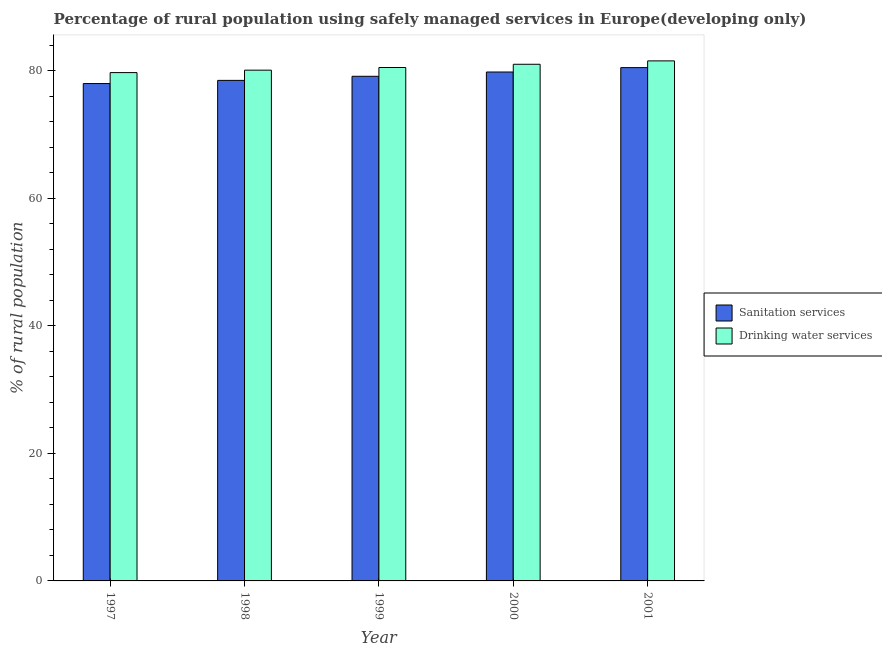How many groups of bars are there?
Your answer should be compact. 5. Are the number of bars per tick equal to the number of legend labels?
Make the answer very short. Yes. How many bars are there on the 3rd tick from the left?
Ensure brevity in your answer.  2. How many bars are there on the 5th tick from the right?
Provide a short and direct response. 2. In how many cases, is the number of bars for a given year not equal to the number of legend labels?
Offer a terse response. 0. What is the percentage of rural population who used sanitation services in 1999?
Your response must be concise. 79.12. Across all years, what is the maximum percentage of rural population who used sanitation services?
Your answer should be compact. 80.48. Across all years, what is the minimum percentage of rural population who used drinking water services?
Provide a short and direct response. 79.7. In which year was the percentage of rural population who used sanitation services minimum?
Your response must be concise. 1997. What is the total percentage of rural population who used drinking water services in the graph?
Provide a short and direct response. 402.84. What is the difference between the percentage of rural population who used sanitation services in 1999 and that in 2000?
Your answer should be compact. -0.67. What is the difference between the percentage of rural population who used sanitation services in 2001 and the percentage of rural population who used drinking water services in 1999?
Offer a very short reply. 1.36. What is the average percentage of rural population who used drinking water services per year?
Make the answer very short. 80.57. In the year 1999, what is the difference between the percentage of rural population who used drinking water services and percentage of rural population who used sanitation services?
Offer a very short reply. 0. In how many years, is the percentage of rural population who used sanitation services greater than 48 %?
Give a very brief answer. 5. What is the ratio of the percentage of rural population who used sanitation services in 2000 to that in 2001?
Provide a succinct answer. 0.99. Is the percentage of rural population who used sanitation services in 1998 less than that in 2000?
Keep it short and to the point. Yes. What is the difference between the highest and the second highest percentage of rural population who used drinking water services?
Provide a short and direct response. 0.53. What is the difference between the highest and the lowest percentage of rural population who used sanitation services?
Ensure brevity in your answer.  2.5. In how many years, is the percentage of rural population who used sanitation services greater than the average percentage of rural population who used sanitation services taken over all years?
Your answer should be compact. 2. Is the sum of the percentage of rural population who used drinking water services in 1997 and 1998 greater than the maximum percentage of rural population who used sanitation services across all years?
Offer a very short reply. Yes. What does the 1st bar from the left in 2000 represents?
Make the answer very short. Sanitation services. What does the 1st bar from the right in 1999 represents?
Your answer should be compact. Drinking water services. Are all the bars in the graph horizontal?
Provide a short and direct response. No. How many years are there in the graph?
Ensure brevity in your answer.  5. What is the difference between two consecutive major ticks on the Y-axis?
Make the answer very short. 20. Does the graph contain any zero values?
Provide a succinct answer. No. Does the graph contain grids?
Provide a short and direct response. No. Where does the legend appear in the graph?
Provide a short and direct response. Center right. What is the title of the graph?
Your answer should be compact. Percentage of rural population using safely managed services in Europe(developing only). What is the label or title of the Y-axis?
Ensure brevity in your answer.  % of rural population. What is the % of rural population in Sanitation services in 1997?
Ensure brevity in your answer.  77.99. What is the % of rural population of Drinking water services in 1997?
Your answer should be compact. 79.7. What is the % of rural population in Sanitation services in 1998?
Make the answer very short. 78.48. What is the % of rural population of Drinking water services in 1998?
Provide a succinct answer. 80.08. What is the % of rural population of Sanitation services in 1999?
Provide a succinct answer. 79.12. What is the % of rural population in Drinking water services in 1999?
Keep it short and to the point. 80.5. What is the % of rural population in Sanitation services in 2000?
Your answer should be very brief. 79.8. What is the % of rural population of Drinking water services in 2000?
Provide a succinct answer. 81.01. What is the % of rural population in Sanitation services in 2001?
Offer a terse response. 80.48. What is the % of rural population of Drinking water services in 2001?
Your response must be concise. 81.54. Across all years, what is the maximum % of rural population of Sanitation services?
Offer a terse response. 80.48. Across all years, what is the maximum % of rural population in Drinking water services?
Offer a very short reply. 81.54. Across all years, what is the minimum % of rural population in Sanitation services?
Offer a very short reply. 77.99. Across all years, what is the minimum % of rural population in Drinking water services?
Give a very brief answer. 79.7. What is the total % of rural population in Sanitation services in the graph?
Ensure brevity in your answer.  395.87. What is the total % of rural population of Drinking water services in the graph?
Give a very brief answer. 402.84. What is the difference between the % of rural population of Sanitation services in 1997 and that in 1998?
Provide a short and direct response. -0.5. What is the difference between the % of rural population of Drinking water services in 1997 and that in 1998?
Ensure brevity in your answer.  -0.38. What is the difference between the % of rural population in Sanitation services in 1997 and that in 1999?
Provide a succinct answer. -1.14. What is the difference between the % of rural population of Drinking water services in 1997 and that in 1999?
Provide a short and direct response. -0.8. What is the difference between the % of rural population in Sanitation services in 1997 and that in 2000?
Ensure brevity in your answer.  -1.81. What is the difference between the % of rural population in Drinking water services in 1997 and that in 2000?
Offer a very short reply. -1.31. What is the difference between the % of rural population of Sanitation services in 1997 and that in 2001?
Your response must be concise. -2.5. What is the difference between the % of rural population in Drinking water services in 1997 and that in 2001?
Ensure brevity in your answer.  -1.84. What is the difference between the % of rural population of Sanitation services in 1998 and that in 1999?
Provide a short and direct response. -0.64. What is the difference between the % of rural population of Drinking water services in 1998 and that in 1999?
Keep it short and to the point. -0.42. What is the difference between the % of rural population of Sanitation services in 1998 and that in 2000?
Your response must be concise. -1.31. What is the difference between the % of rural population of Drinking water services in 1998 and that in 2000?
Offer a terse response. -0.92. What is the difference between the % of rural population of Sanitation services in 1998 and that in 2001?
Your answer should be very brief. -2. What is the difference between the % of rural population of Drinking water services in 1998 and that in 2001?
Provide a succinct answer. -1.46. What is the difference between the % of rural population of Sanitation services in 1999 and that in 2000?
Ensure brevity in your answer.  -0.67. What is the difference between the % of rural population of Drinking water services in 1999 and that in 2000?
Your response must be concise. -0.51. What is the difference between the % of rural population of Sanitation services in 1999 and that in 2001?
Offer a terse response. -1.36. What is the difference between the % of rural population of Drinking water services in 1999 and that in 2001?
Offer a terse response. -1.04. What is the difference between the % of rural population of Sanitation services in 2000 and that in 2001?
Your response must be concise. -0.69. What is the difference between the % of rural population in Drinking water services in 2000 and that in 2001?
Provide a short and direct response. -0.53. What is the difference between the % of rural population in Sanitation services in 1997 and the % of rural population in Drinking water services in 1998?
Give a very brief answer. -2.1. What is the difference between the % of rural population in Sanitation services in 1997 and the % of rural population in Drinking water services in 1999?
Give a very brief answer. -2.52. What is the difference between the % of rural population in Sanitation services in 1997 and the % of rural population in Drinking water services in 2000?
Provide a short and direct response. -3.02. What is the difference between the % of rural population of Sanitation services in 1997 and the % of rural population of Drinking water services in 2001?
Provide a short and direct response. -3.56. What is the difference between the % of rural population in Sanitation services in 1998 and the % of rural population in Drinking water services in 1999?
Give a very brief answer. -2.02. What is the difference between the % of rural population of Sanitation services in 1998 and the % of rural population of Drinking water services in 2000?
Provide a succinct answer. -2.53. What is the difference between the % of rural population in Sanitation services in 1998 and the % of rural population in Drinking water services in 2001?
Provide a short and direct response. -3.06. What is the difference between the % of rural population of Sanitation services in 1999 and the % of rural population of Drinking water services in 2000?
Offer a very short reply. -1.88. What is the difference between the % of rural population of Sanitation services in 1999 and the % of rural population of Drinking water services in 2001?
Make the answer very short. -2.42. What is the difference between the % of rural population of Sanitation services in 2000 and the % of rural population of Drinking water services in 2001?
Your answer should be compact. -1.74. What is the average % of rural population of Sanitation services per year?
Make the answer very short. 79.17. What is the average % of rural population of Drinking water services per year?
Keep it short and to the point. 80.57. In the year 1997, what is the difference between the % of rural population of Sanitation services and % of rural population of Drinking water services?
Your answer should be very brief. -1.72. In the year 1998, what is the difference between the % of rural population in Sanitation services and % of rural population in Drinking water services?
Provide a succinct answer. -1.6. In the year 1999, what is the difference between the % of rural population of Sanitation services and % of rural population of Drinking water services?
Provide a succinct answer. -1.38. In the year 2000, what is the difference between the % of rural population in Sanitation services and % of rural population in Drinking water services?
Your answer should be compact. -1.21. In the year 2001, what is the difference between the % of rural population of Sanitation services and % of rural population of Drinking water services?
Provide a short and direct response. -1.06. What is the ratio of the % of rural population in Drinking water services in 1997 to that in 1998?
Keep it short and to the point. 1. What is the ratio of the % of rural population in Sanitation services in 1997 to that in 1999?
Provide a short and direct response. 0.99. What is the ratio of the % of rural population in Sanitation services in 1997 to that in 2000?
Make the answer very short. 0.98. What is the ratio of the % of rural population of Drinking water services in 1997 to that in 2000?
Your response must be concise. 0.98. What is the ratio of the % of rural population in Sanitation services in 1997 to that in 2001?
Give a very brief answer. 0.97. What is the ratio of the % of rural population of Drinking water services in 1997 to that in 2001?
Your answer should be compact. 0.98. What is the ratio of the % of rural population in Sanitation services in 1998 to that in 2000?
Your answer should be compact. 0.98. What is the ratio of the % of rural population in Drinking water services in 1998 to that in 2000?
Provide a short and direct response. 0.99. What is the ratio of the % of rural population in Sanitation services in 1998 to that in 2001?
Provide a short and direct response. 0.98. What is the ratio of the % of rural population of Drinking water services in 1998 to that in 2001?
Offer a very short reply. 0.98. What is the ratio of the % of rural population in Sanitation services in 1999 to that in 2000?
Your answer should be very brief. 0.99. What is the ratio of the % of rural population of Sanitation services in 1999 to that in 2001?
Your answer should be compact. 0.98. What is the ratio of the % of rural population in Drinking water services in 1999 to that in 2001?
Your answer should be compact. 0.99. What is the ratio of the % of rural population in Drinking water services in 2000 to that in 2001?
Your answer should be compact. 0.99. What is the difference between the highest and the second highest % of rural population of Sanitation services?
Offer a very short reply. 0.69. What is the difference between the highest and the second highest % of rural population of Drinking water services?
Provide a short and direct response. 0.53. What is the difference between the highest and the lowest % of rural population in Sanitation services?
Offer a terse response. 2.5. What is the difference between the highest and the lowest % of rural population in Drinking water services?
Your response must be concise. 1.84. 